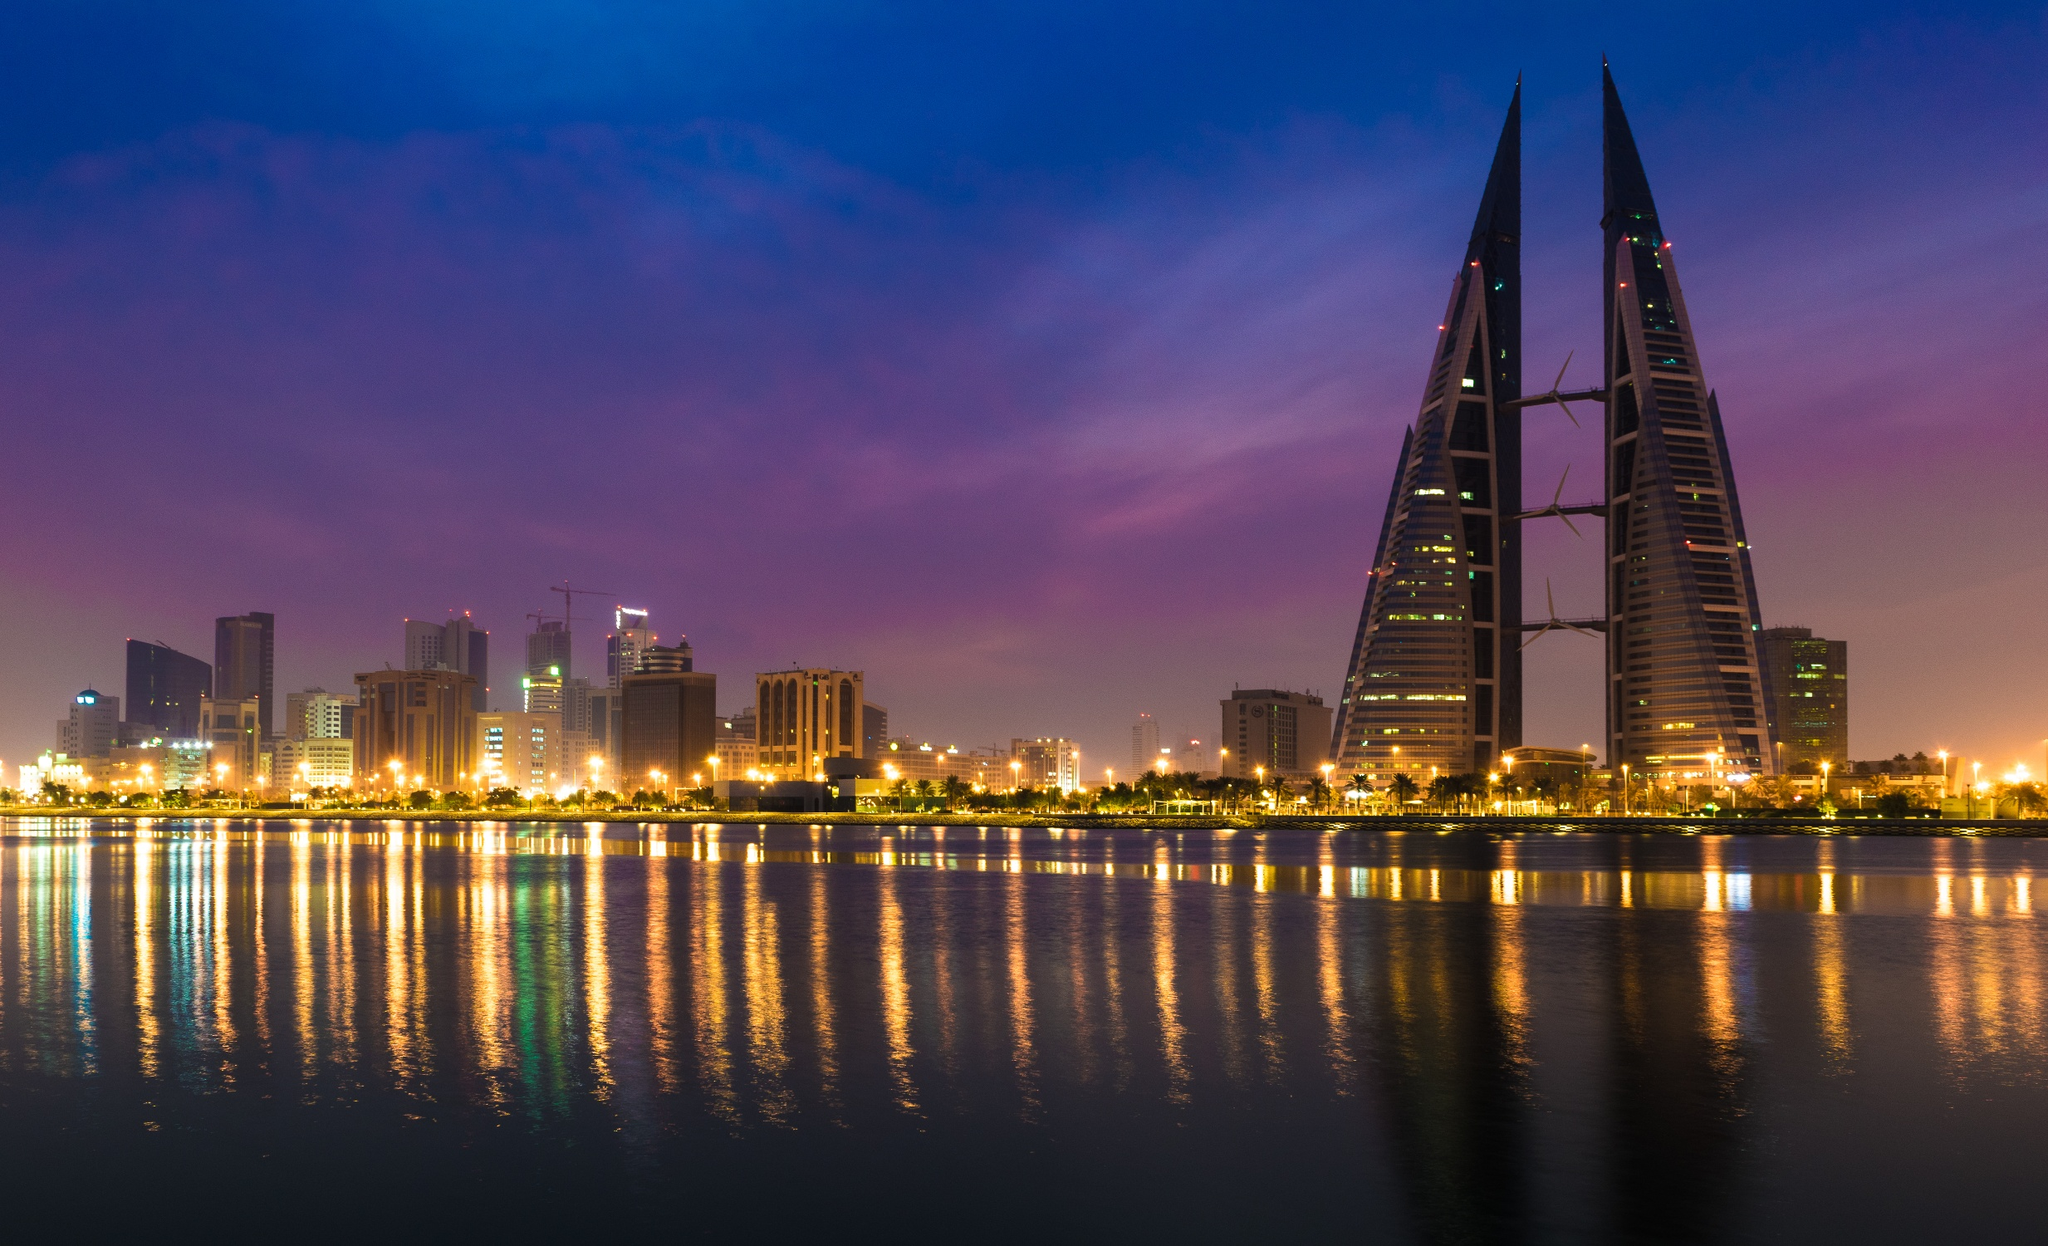Could you tell a story inspired by this scene? In a city where the desert meets the sea, the Bahrain World Trade Center stood as a beacon of innovation. As the sun set, casting hues of lavender and rose across the sky, a young architect named Leila stood at the waterfront. She had always been fascinated by the towers' unique design and their promise of sustainability. Tonight, the reflection of the towers on the tranquil waters mirrored her dreams. She envisioned a future where buildings across Bahrain would similarly harness the elements to create a harmonious balance between nature and urban life. As she watched the lights flicker on, she felt a renewed sense of purpose, knowing that her journey in sustainable architecture had just begun. The night embraced the city in its serene glow, and with it, Leila stepped forward, inspired to carve her own path in the annals of architectural history. Now, imagine this scene 50 years into the future. What changes do you foresee? Fifty years into the future, the skyline of Manama has transformed dramatically. The Bahrain World Trade Center still stands as an iconic monument, but it is now surrounded by an array of equally sustainable and avant-garde structures. The waterfront has evolved into a lush, green promenade with solar trees that provide shade and harness solar power. Underwater bioluminescent parks glow beneath the surface, creating a magical ambiance. Drones zip through the skies, delivering goods efficiently to the floating solar-powered docks. The city's energy grid is now entirely renewable, with advancements in technology making harnessing wind, solar, and tidal power highly efficient. The skyline is a brilliant mix of greenery, futuristic designs, and advanced tech solutions, depicting a perfect symbiosis between mankind and the environment. Imagine a fantasy scenario where these towers are magical. What powers do they hold? In a world where magic prevails, the Bahrain World Trade Center is not just an architectural marvel, but also the mystical Guardians of the Sky. The towers, glimmering with enchanted lights, hold the power to control the elements. During the day, they can summon gentle winds and rainbows to nourish the city below, ensuring a bountiful harvest. At night, the towers become lighthouses of hope, casting protective spells that keep the city safe from any harm. The three wind turbines, though looking ordinary, are actually portals to different realms, offering passage to mystical lands where seekers of wisdom venture. These towers are governed by an ancient council of mages who reside in secret chambers within, ensuring that their magical powers are used only for the good of humanity and nature. The city thrives under their guardianship, a testament to the harmonious blend of magic and human architecture. 